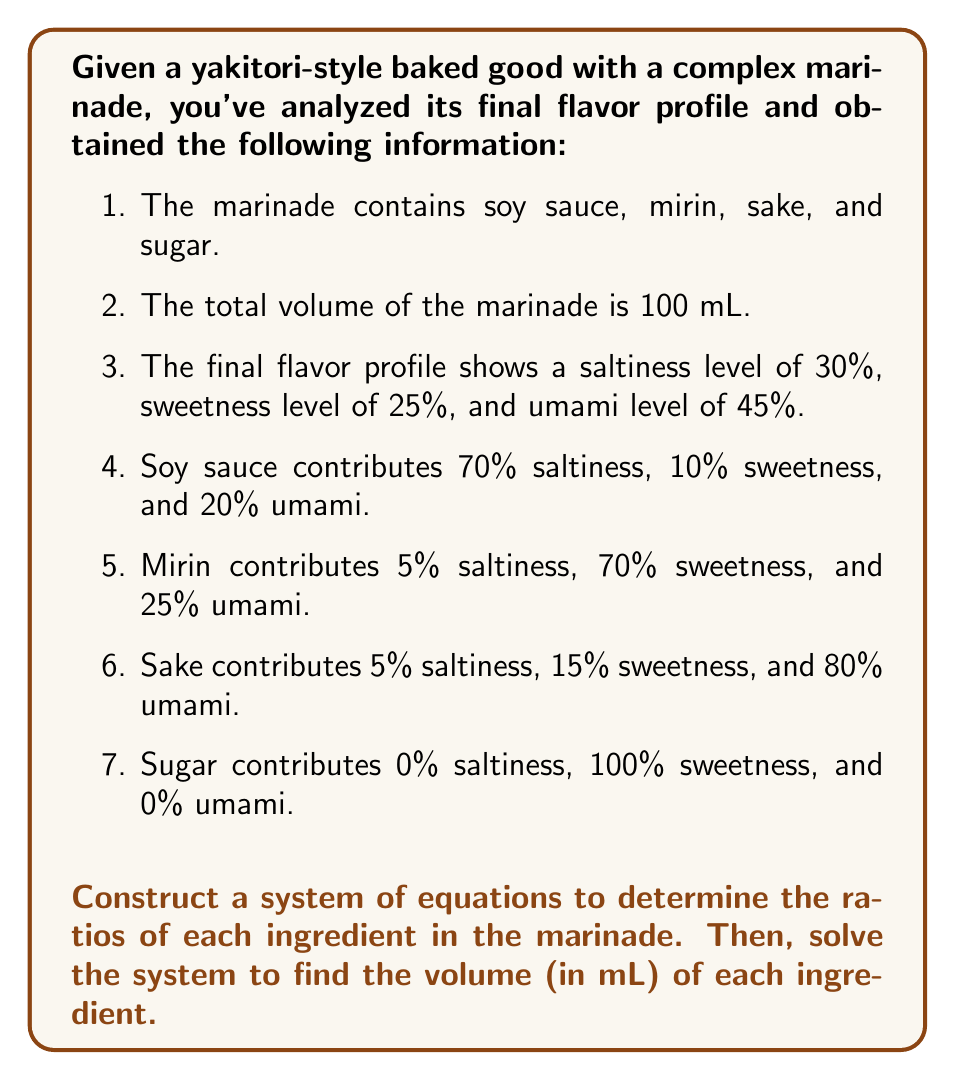Give your solution to this math problem. Let's approach this step-by-step:

1) Let $x$, $y$, $z$, and $w$ represent the volumes (in mL) of soy sauce, mirin, sake, and sugar respectively.

2) First, we know that the total volume is 100 mL:

   $$x + y + z + w = 100$$

3) Now, let's set up equations for each flavor component:

   Saltiness: $0.7x + 0.05y + 0.05z + 0w = 30$
   Sweetness: $0.1x + 0.7y + 0.15z + 1w = 25$
   Umami: $0.2x + 0.25y + 0.8z + 0w = 45$

4) We now have a system of 4 equations with 4 unknowns:

   $$\begin{cases}
   x + y + z + w = 100 \\
   0.7x + 0.05y + 0.05z = 30 \\
   0.1x + 0.7y + 0.15z + w = 25 \\
   0.2x + 0.25y + 0.8z = 45
   \end{cases}$$

5) This system can be solved using matrix methods or substitution. Using a computer algebra system, we get:

   $x \approx 40.54$
   $y \approx 22.97$
   $z \approx 31.08$
   $w \approx 5.41$

6) Rounding to the nearest mL:

   Soy sauce: 41 mL
   Mirin: 23 mL
   Sake: 31 mL
   Sugar: 5 mL

These volumes represent the ratios of the traditional Japanese seasonings in the complex marinade.
Answer: Soy sauce: 41 mL, Mirin: 23 mL, Sake: 31 mL, Sugar: 5 mL 